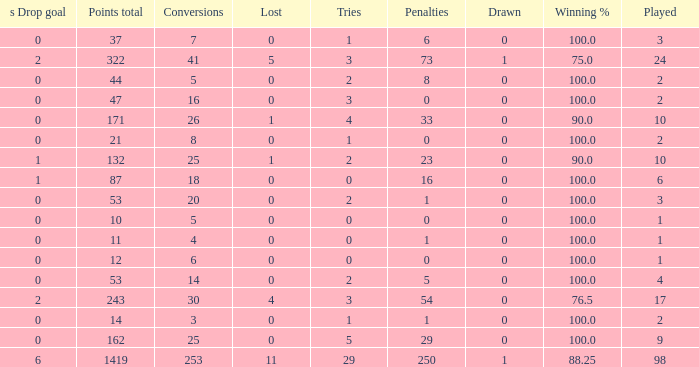How many ties did he have when he had 1 penalties and more than 20 conversions? None. Parse the full table. {'header': ['s Drop goal', 'Points total', 'Conversions', 'Lost', 'Tries', 'Penalties', 'Drawn', 'Winning %', 'Played'], 'rows': [['0', '37', '7', '0', '1', '6', '0', '100.0', '3'], ['2', '322', '41', '5', '3', '73', '1', '75.0', '24'], ['0', '44', '5', '0', '2', '8', '0', '100.0', '2'], ['0', '47', '16', '0', '3', '0', '0', '100.0', '2'], ['0', '171', '26', '1', '4', '33', '0', '90.0', '10'], ['0', '21', '8', '0', '1', '0', '0', '100.0', '2'], ['1', '132', '25', '1', '2', '23', '0', '90.0', '10'], ['1', '87', '18', '0', '0', '16', '0', '100.0', '6'], ['0', '53', '20', '0', '2', '1', '0', '100.0', '3'], ['0', '10', '5', '0', '0', '0', '0', '100.0', '1'], ['0', '11', '4', '0', '0', '1', '0', '100.0', '1'], ['0', '12', '6', '0', '0', '0', '0', '100.0', '1'], ['0', '53', '14', '0', '2', '5', '0', '100.0', '4'], ['2', '243', '30', '4', '3', '54', '0', '76.5', '17'], ['0', '14', '3', '0', '1', '1', '0', '100.0', '2'], ['0', '162', '25', '0', '5', '29', '0', '100.0', '9'], ['6', '1419', '253', '11', '29', '250', '1', '88.25', '98']]} 